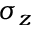<formula> <loc_0><loc_0><loc_500><loc_500>\sigma _ { z }</formula> 